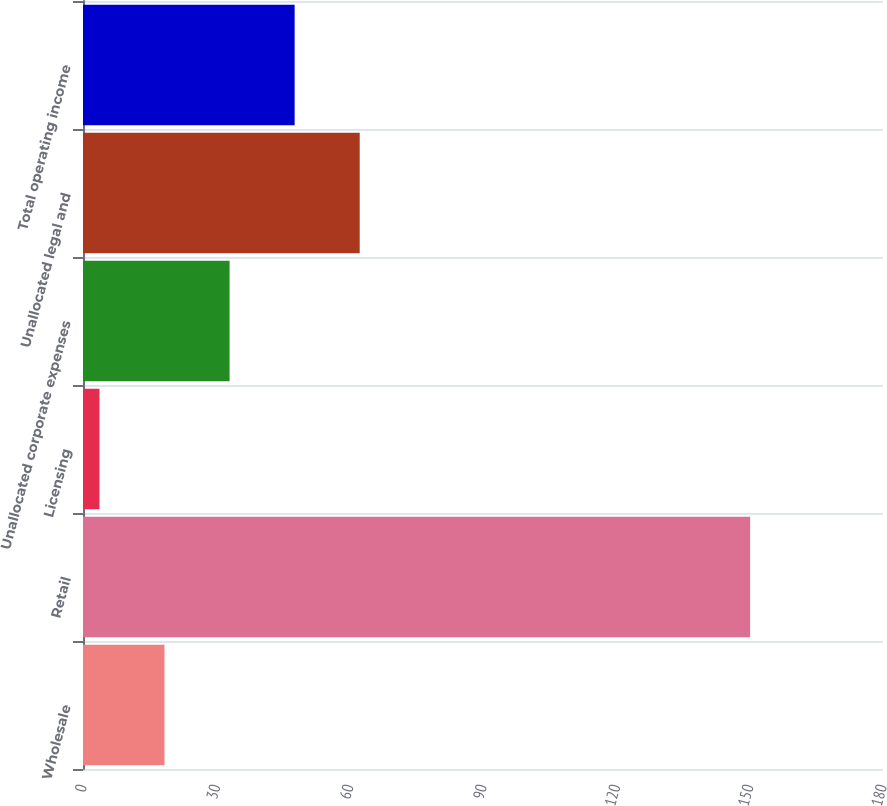Convert chart. <chart><loc_0><loc_0><loc_500><loc_500><bar_chart><fcel>Wholesale<fcel>Retail<fcel>Licensing<fcel>Unallocated corporate expenses<fcel>Unallocated legal and<fcel>Total operating income<nl><fcel>18.34<fcel>150.1<fcel>3.7<fcel>32.98<fcel>62.26<fcel>47.62<nl></chart> 